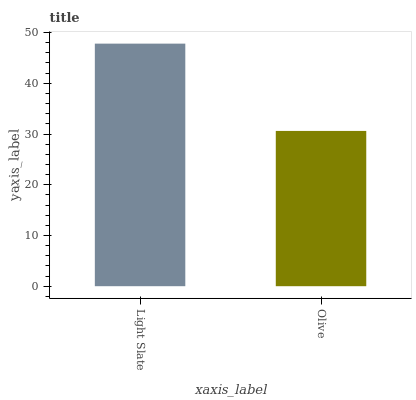Is Olive the minimum?
Answer yes or no. Yes. Is Light Slate the maximum?
Answer yes or no. Yes. Is Olive the maximum?
Answer yes or no. No. Is Light Slate greater than Olive?
Answer yes or no. Yes. Is Olive less than Light Slate?
Answer yes or no. Yes. Is Olive greater than Light Slate?
Answer yes or no. No. Is Light Slate less than Olive?
Answer yes or no. No. Is Light Slate the high median?
Answer yes or no. Yes. Is Olive the low median?
Answer yes or no. Yes. Is Olive the high median?
Answer yes or no. No. Is Light Slate the low median?
Answer yes or no. No. 